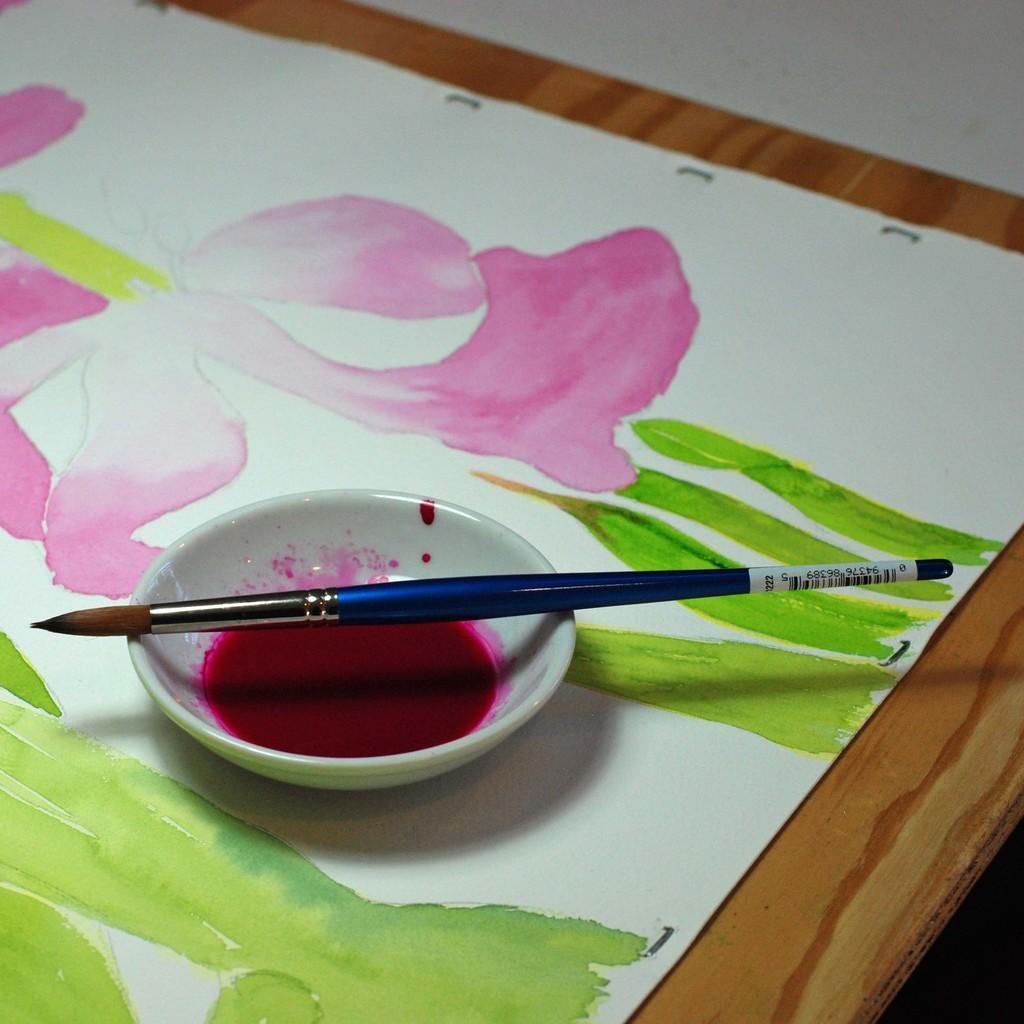In one or two sentences, can you explain what this image depicts? In this picture we can see a table, there is a painting board present in the table, we can also see a bowl and a brush, there is some color in this bowl. 